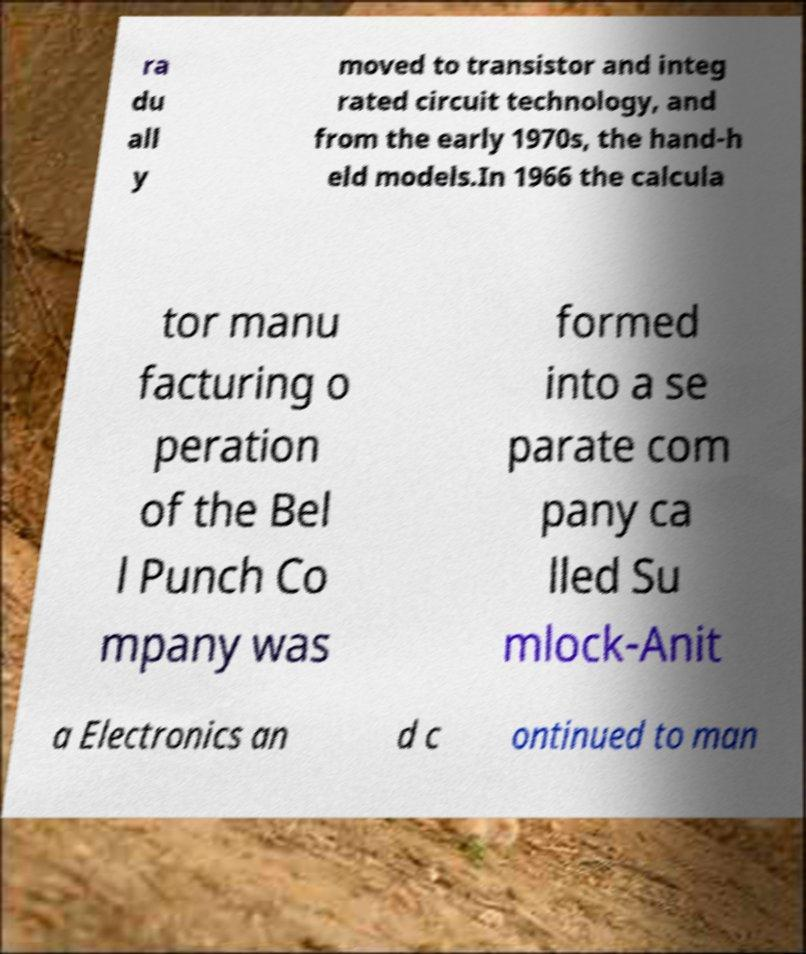What messages or text are displayed in this image? I need them in a readable, typed format. ra du all y moved to transistor and integ rated circuit technology, and from the early 1970s, the hand-h eld models.In 1966 the calcula tor manu facturing o peration of the Bel l Punch Co mpany was formed into a se parate com pany ca lled Su mlock-Anit a Electronics an d c ontinued to man 